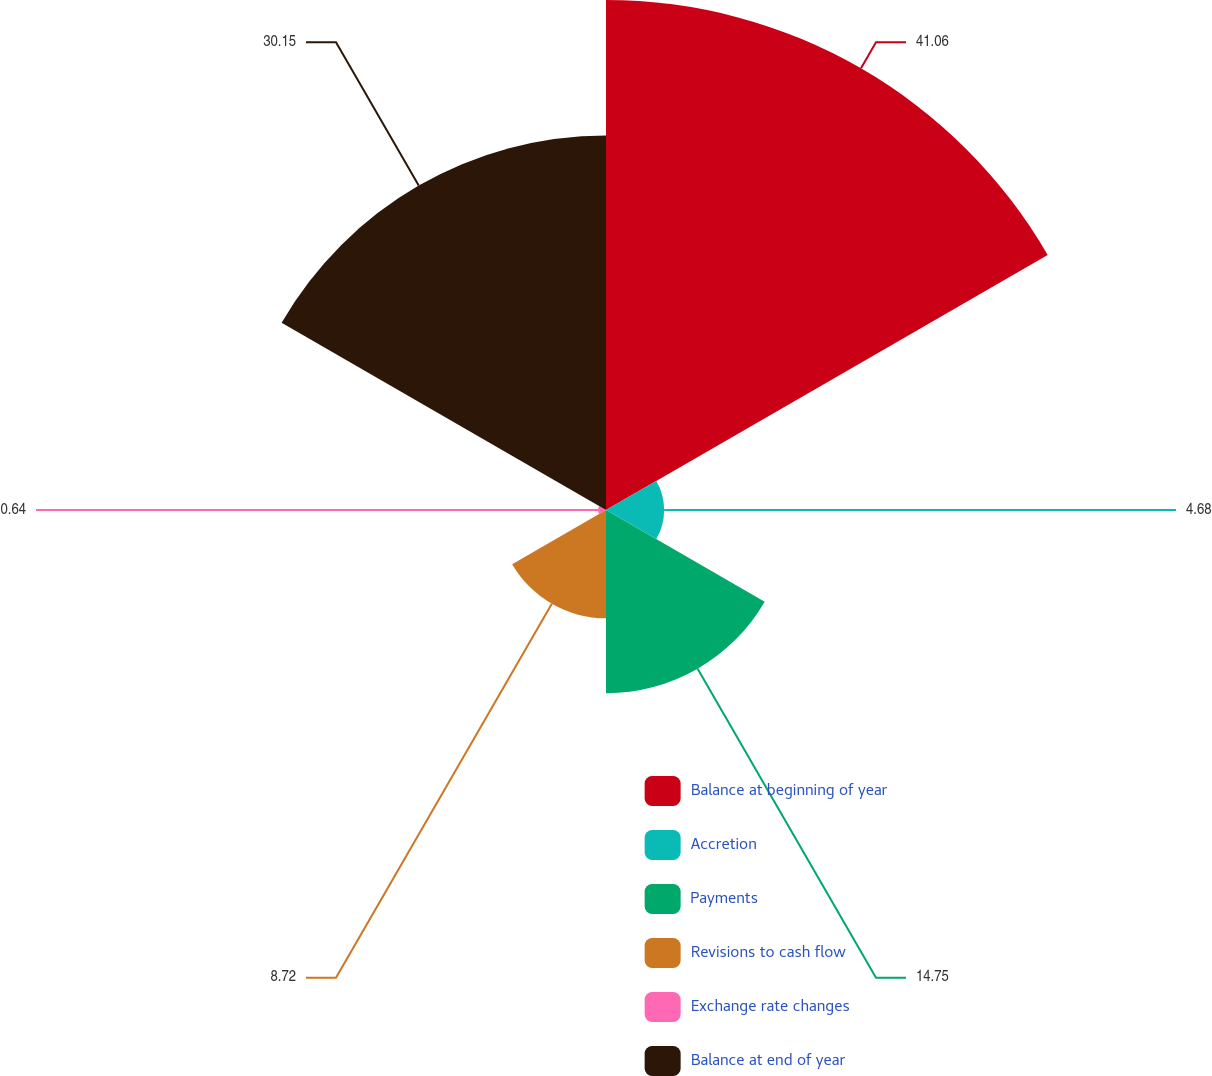<chart> <loc_0><loc_0><loc_500><loc_500><pie_chart><fcel>Balance at beginning of year<fcel>Accretion<fcel>Payments<fcel>Revisions to cash flow<fcel>Exchange rate changes<fcel>Balance at end of year<nl><fcel>41.05%<fcel>4.68%<fcel>14.75%<fcel>8.72%<fcel>0.64%<fcel>30.15%<nl></chart> 